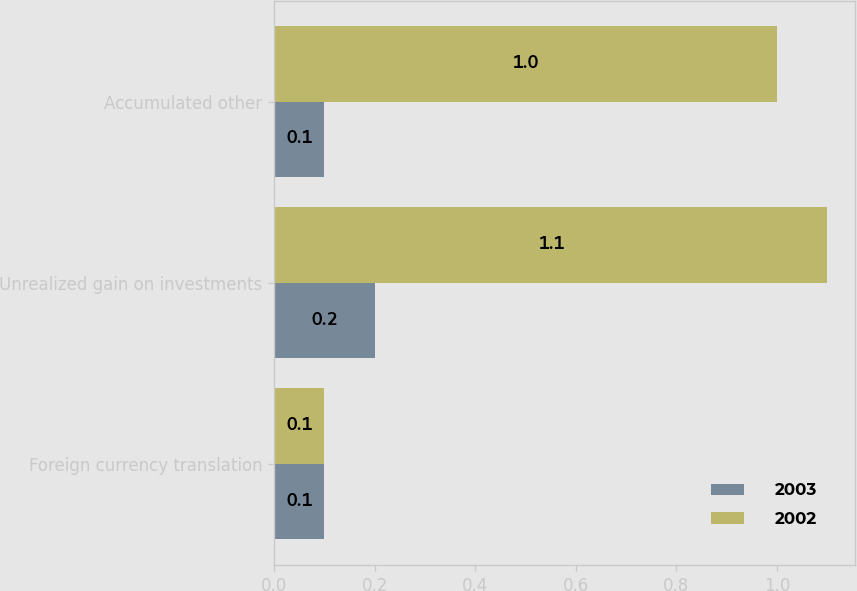Convert chart. <chart><loc_0><loc_0><loc_500><loc_500><stacked_bar_chart><ecel><fcel>Foreign currency translation<fcel>Unrealized gain on investments<fcel>Accumulated other<nl><fcel>2003<fcel>0.1<fcel>0.2<fcel>0.1<nl><fcel>2002<fcel>0.1<fcel>1.1<fcel>1<nl></chart> 